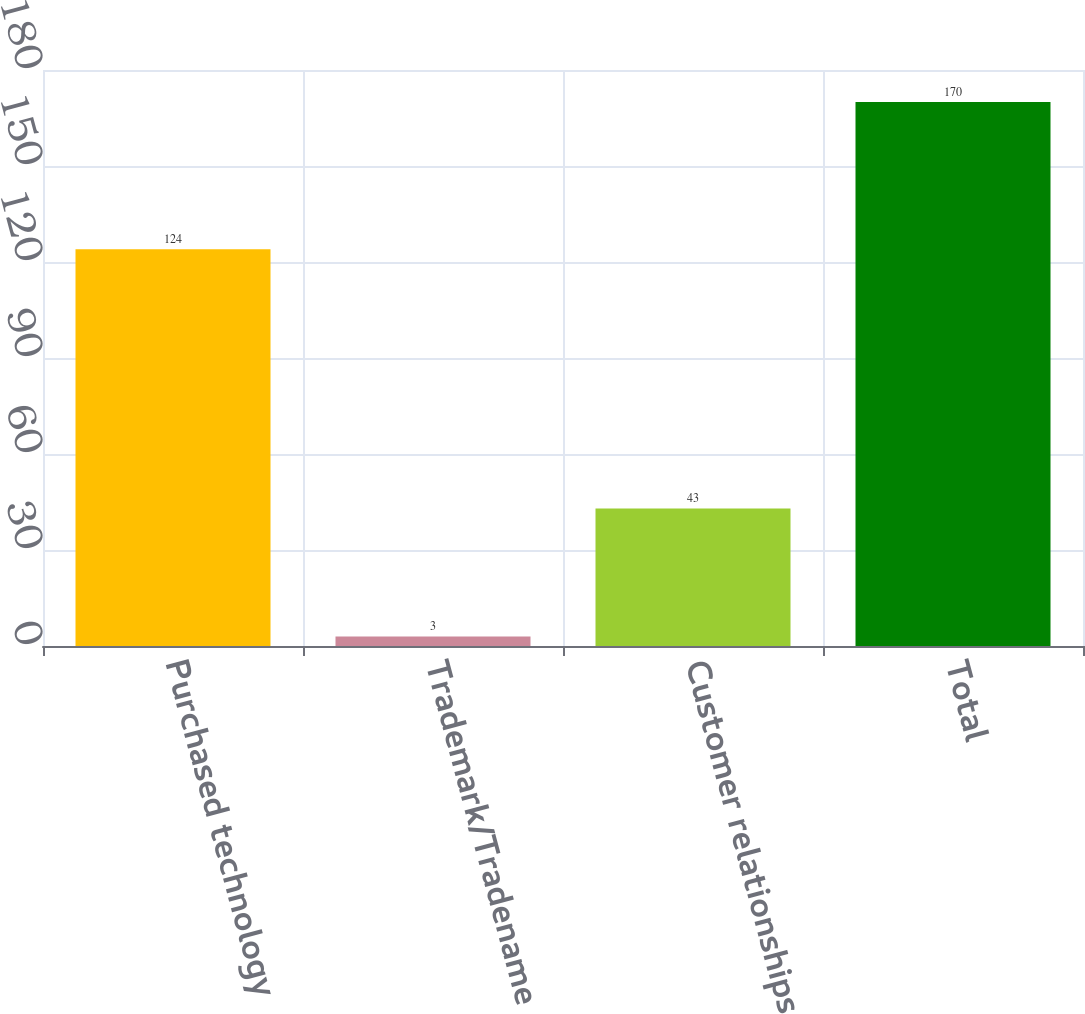<chart> <loc_0><loc_0><loc_500><loc_500><bar_chart><fcel>Purchased technology<fcel>Trademark/Tradename<fcel>Customer relationships<fcel>Total<nl><fcel>124<fcel>3<fcel>43<fcel>170<nl></chart> 